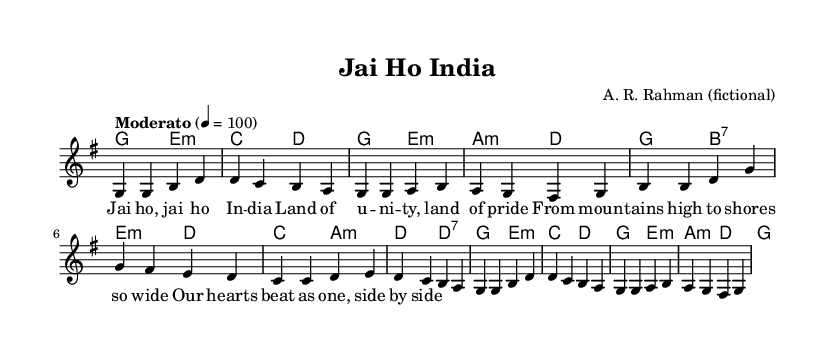What is the key signature of this music? The key signature is G major, which has one sharp (F#). This is indicated at the beginning of the sheet music where the key signature is shown.
Answer: G major What is the time signature of the piece? The time signature displayed in the sheet music is 4/4, which indicates that there are four beats per measure and the quarter note receives one beat. This is confirmed by the time signature notation found at the start of the score.
Answer: 4/4 What is the tempo marking for this song? The tempo marking in the sheet music indicates "Moderato" with a metronome marking of 100 beats per minute. This guiding instruction helps performers know the speed at which to play the piece, evident in the tempo indication section.
Answer: Moderato 100 How many measures are in the melody section? The melody is structured into 12 measures, which can be counted by looking at the vertical lines (bar lines) throughout the melody staff. Each group of notes between two bar lines constitutes one measure.
Answer: 12 What is the title of the song? The title of the song is "Jai Ho India", as prominently displayed at the top of the sheet music within the header section. This title identifies the name under which the song is known.
Answer: Jai Ho India Who is the composer of this piece? The composer attributed to this fictional title is A. R. Rahman, which is also found in the header section of the music sheet, showing the creator's name associated with this composition.
Answer: A. R. Rahman 